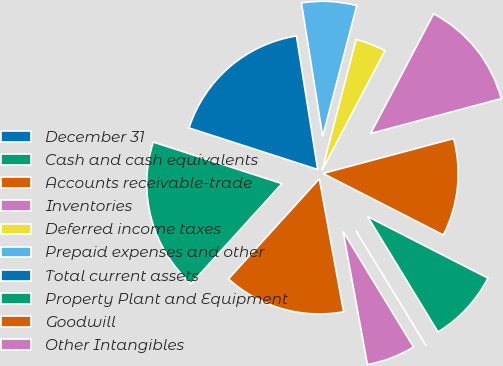Convert chart. <chart><loc_0><loc_0><loc_500><loc_500><pie_chart><fcel>December 31<fcel>Cash and cash equivalents<fcel>Accounts receivable-trade<fcel>Inventories<fcel>Deferred income taxes<fcel>Prepaid expenses and other<fcel>Total current assets<fcel>Property Plant and Equipment<fcel>Goodwill<fcel>Other Intangibles<nl><fcel>0.0%<fcel>8.76%<fcel>11.68%<fcel>13.14%<fcel>3.65%<fcel>6.57%<fcel>17.52%<fcel>18.25%<fcel>14.6%<fcel>5.84%<nl></chart> 